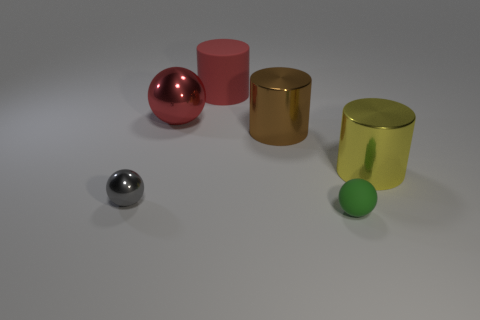How many other objects are there of the same size as the gray metal ball?
Keep it short and to the point. 1. How big is the metal thing that is left of the tiny rubber object and on the right side of the big rubber cylinder?
Your answer should be compact. Large. What number of large brown objects have the same shape as the small green object?
Ensure brevity in your answer.  0. What is the green object made of?
Provide a succinct answer. Rubber. Do the big brown metallic thing and the big red shiny object have the same shape?
Offer a terse response. No. Is there a big yellow cylinder made of the same material as the small gray object?
Your response must be concise. Yes. The ball that is both behind the tiny green matte sphere and in front of the red sphere is what color?
Make the answer very short. Gray. There is a small ball that is right of the large rubber thing; what is it made of?
Your response must be concise. Rubber. Is there another small rubber thing of the same shape as the red rubber thing?
Ensure brevity in your answer.  No. How many other objects are there of the same shape as the brown metallic thing?
Your answer should be compact. 2. 